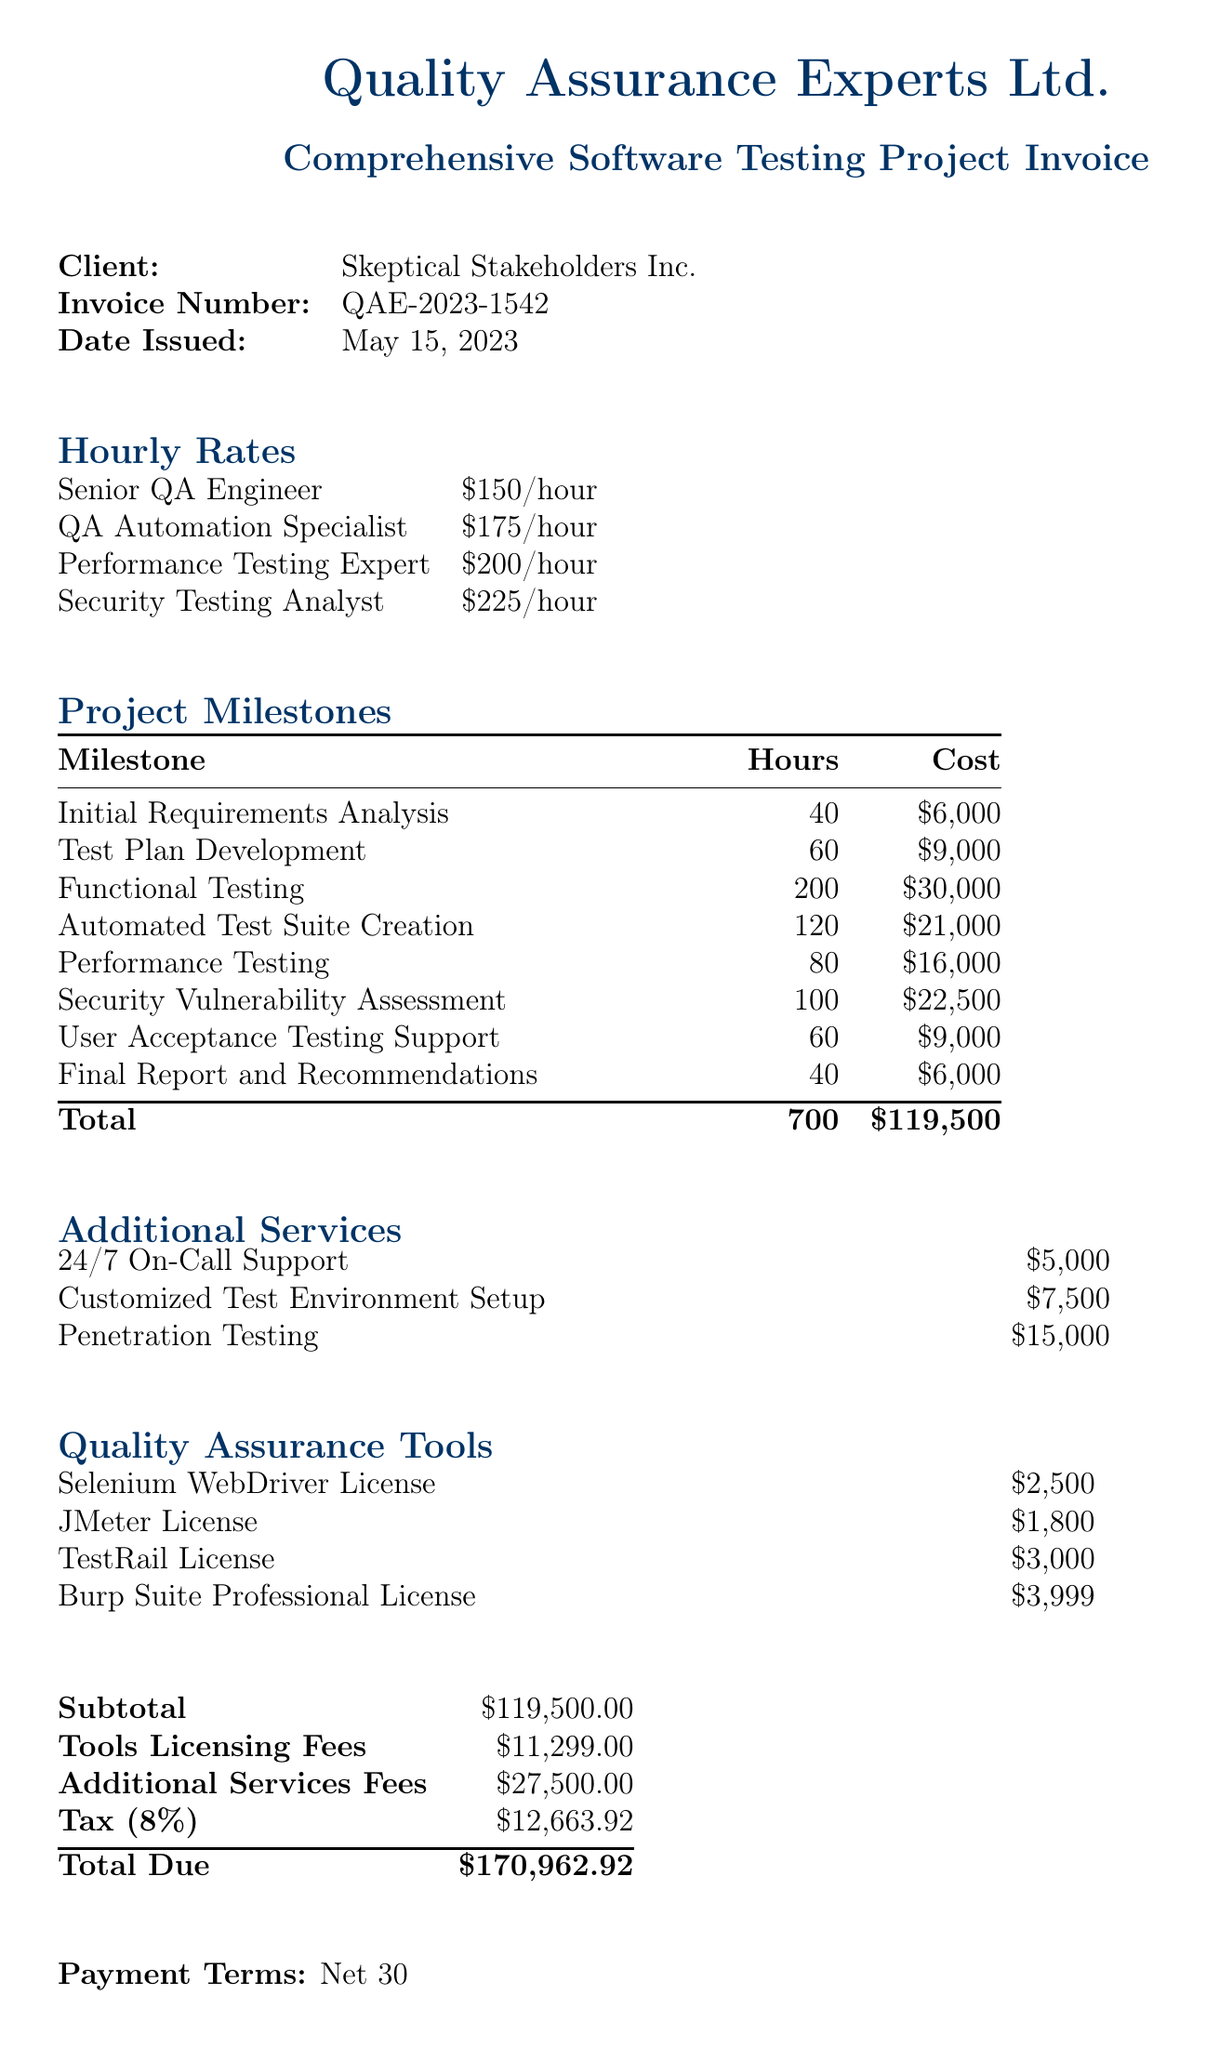What is the invoice number? The invoice number provided in the document is a unique identifier for this transaction.
Answer: QAE-2023-1542 What is the total due amount? The total due amount is calculated by adding the subtotal, tools licensing fees, additional services fees, and tax.
Answer: $170,962.92 How many hours are allocated for Functional Testing? The document specifies the number of hours dedicated to each milestone, including Functional Testing.
Answer: 200 What is the hourly rate for a Security Testing Analyst? The hourly rate for each role is outlined in the document, including the rate for Security Testing Analyst.
Answer: $225 What additional service costs $15,000? The document lists various additional services with their corresponding costs.
Answer: Penetration Testing What is the tax rate applied in the invoice? The tax rate is a percentage that is applied to the subtotal, as indicated in the document.
Answer: 8% How many hours are listed for the Initial Requirements Analysis? The document details the hours allotted for each project milestone, including Initial Requirements Analysis.
Answer: 40 What are the payment terms specified in the document? Payment terms outline the conditions under which payment is expected and are explicitly stated.
Answer: Net 30 What is the subtotal before tax and additional fees? The subtotal is the sum of the costs of all billed milestones before adding any fees or taxes.
Answer: $119,500.00 